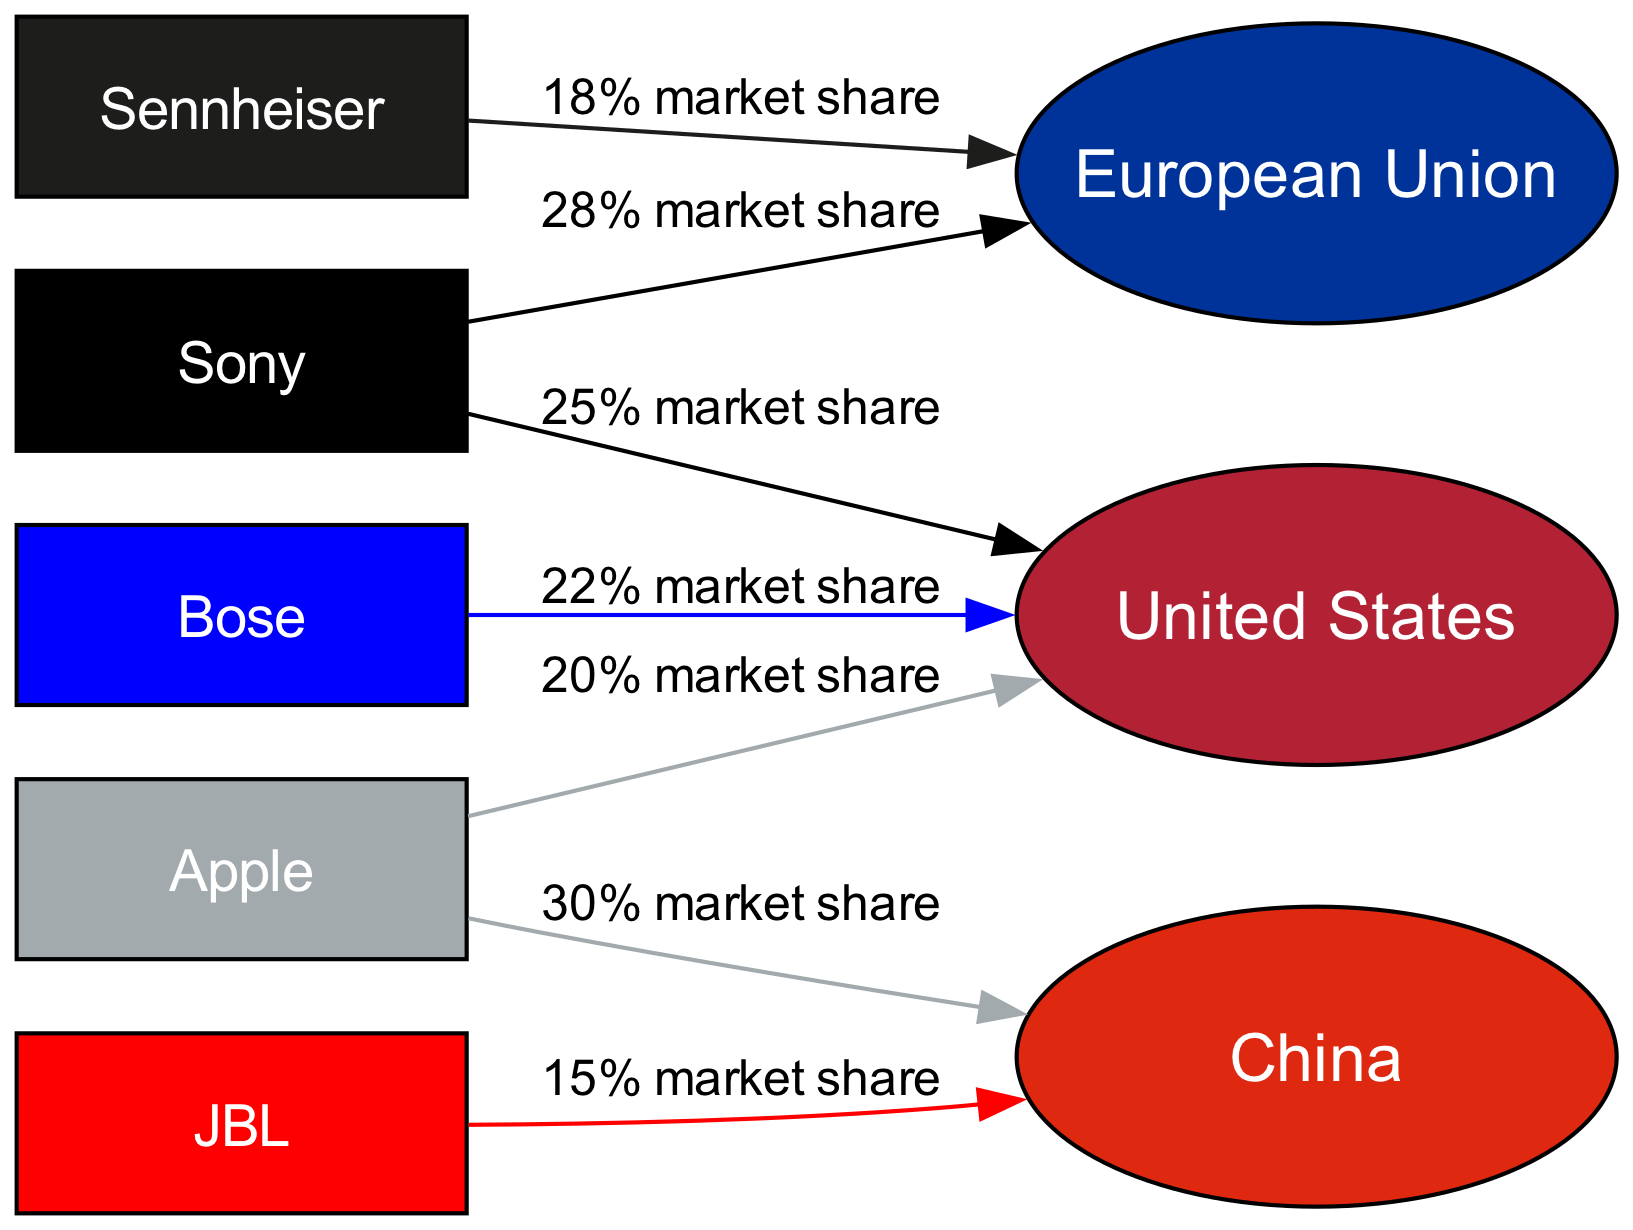What is the market share of Sony in the United States? The edge from Sony to US states "25% market share," indicating that this is the specific market share value.
Answer: 25% market share Which brand holds the highest market share in China? The edge from Apple to China states "30% market share," and no other brand is connected to China in the diagram, indicating that Apple has the highest market share.
Answer: Apple How many total brands are represented in this diagram? The diagram includes 5 brands (Sony, Bose, Apple, Sennheiser, JBL), which can be counted from the nodes.
Answer: 5 Which brand has the lowest market share in the European Union? Looking at the edges leading into the EU, Sennheiser has a market share of "18%," which is less than Sony's "28%" and no other brands are listed for the EU.
Answer: Sennheiser What is the total market share percentage for Sony across the United States and European Union? Summing the market shares: 25% in the US and 28% in the EU gives 25 + 28 = 53%.
Answer: 53% How many edges are shown in the diagram? The diagram has four edges, representing relationships between brands and markets (Sony->US, Bose->US, Sony->EU, Apple->China, Sennheiser->EU, JBL->China).
Answer: 6 Which brand has a market share in both the United States and the European Union? The only brand that has connections to both is Sony, indicated by edges pointing to both US and EU.
Answer: Sony What is the market share of JBL in China? The edge from JBL to China states "15% market share," so that is the specific percentage for JBL in China.
Answer: 15% market share Which market has the highest total share from the brands presented? Evaluating the market shares presented: US has 25% (Sony) + 22% (Bose) + 20% (Apple) = 67%, EU has 28% (Sony) + 18% (Sennheiser) = 46%, and China has 30% (Apple) + 15% (JBL) = 45%. Thus, the US has the highest total.
Answer: United States 